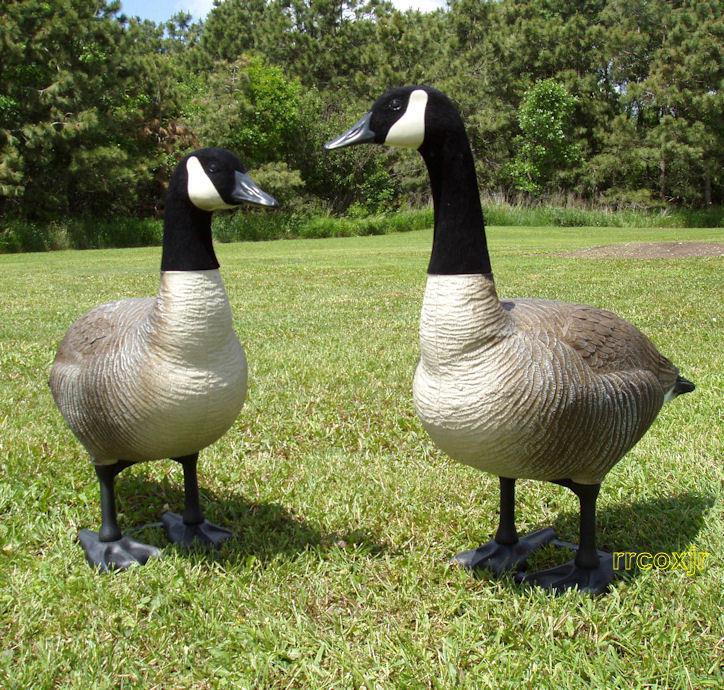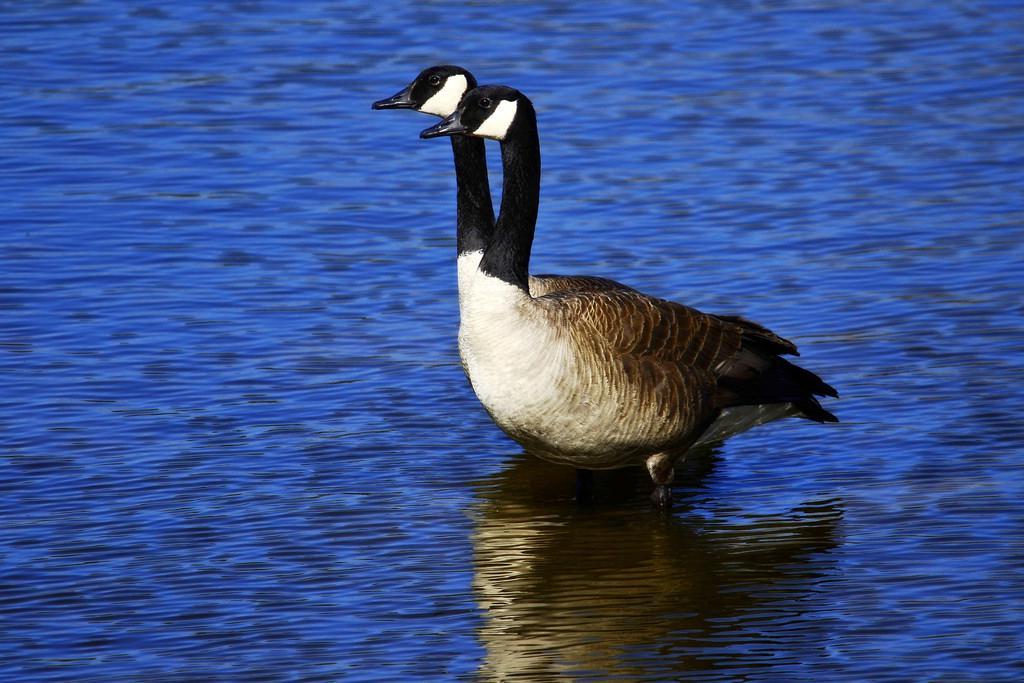The first image is the image on the left, the second image is the image on the right. Examine the images to the left and right. Is the description "there are 2 geese with black and white heads standing on the grass with their shadow next to them" accurate? Answer yes or no. Yes. The first image is the image on the left, the second image is the image on the right. Given the left and right images, does the statement "The left image shows two geese standing with bodies overlapping and upright heads close together and facing left." hold true? Answer yes or no. No. 